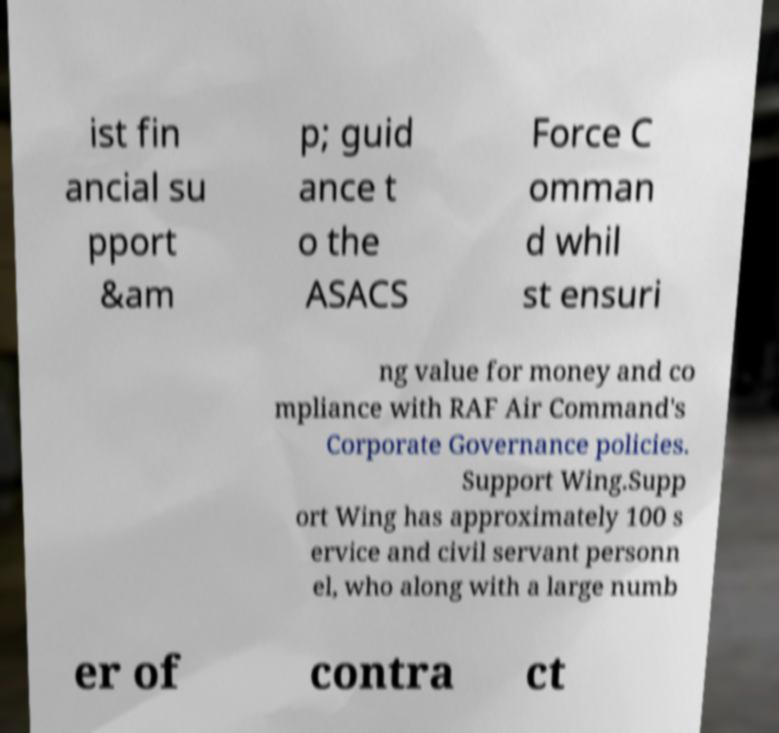What messages or text are displayed in this image? I need them in a readable, typed format. ist fin ancial su pport &am p; guid ance t o the ASACS Force C omman d whil st ensuri ng value for money and co mpliance with RAF Air Command's Corporate Governance policies. Support Wing.Supp ort Wing has approximately 100 s ervice and civil servant personn el, who along with a large numb er of contra ct 